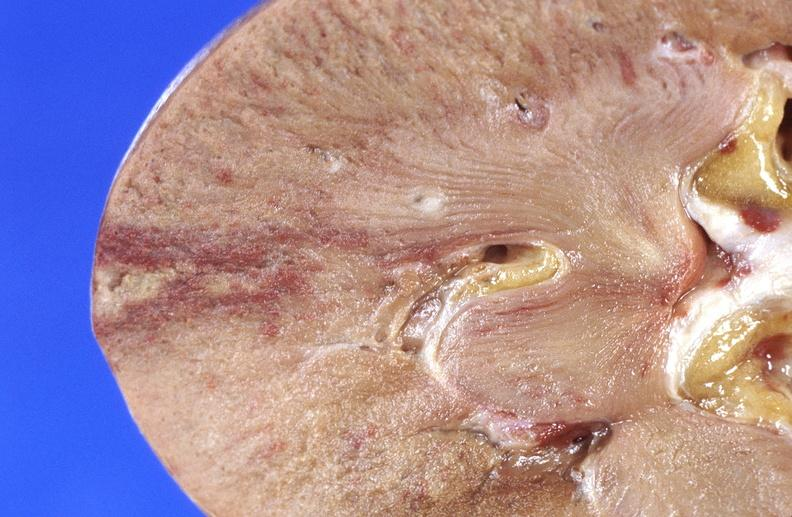does large gland show kidney infarct?
Answer the question using a single word or phrase. No 